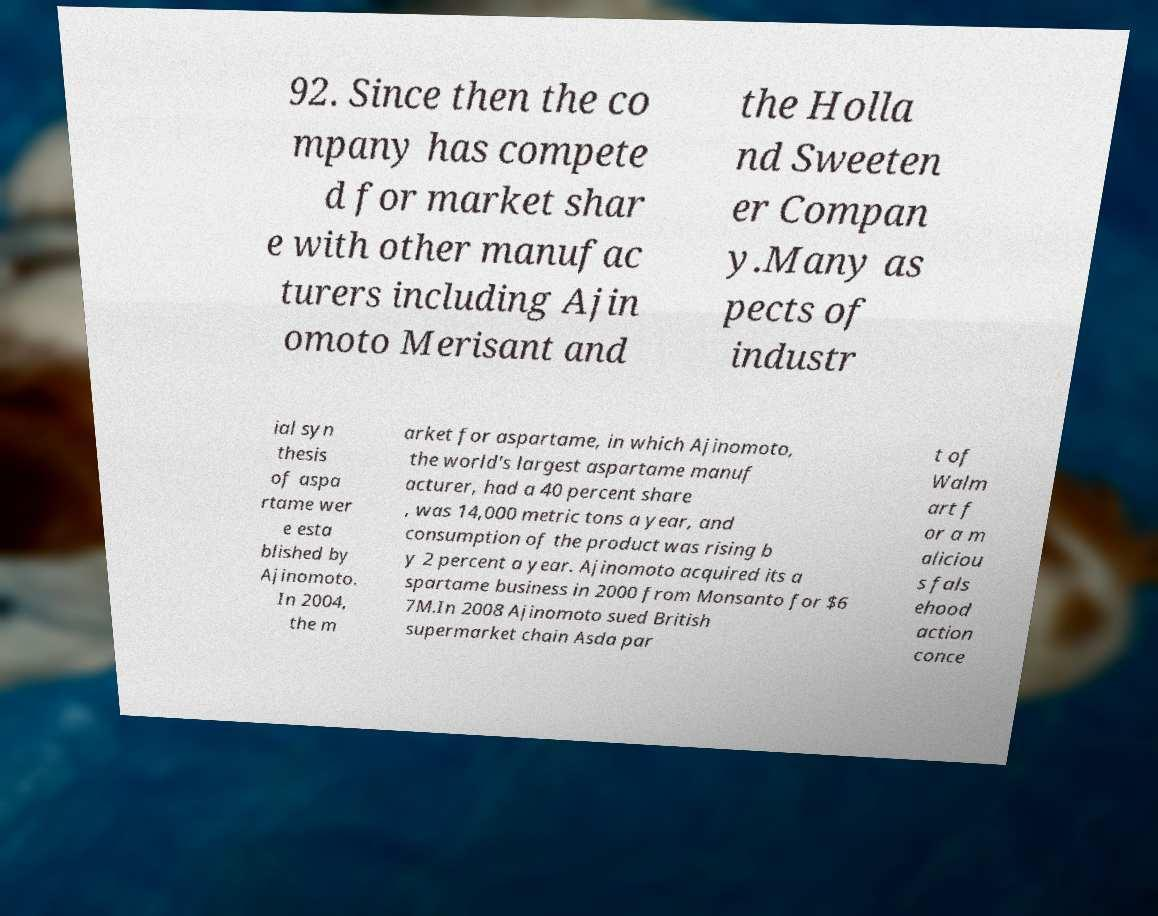Can you accurately transcribe the text from the provided image for me? 92. Since then the co mpany has compete d for market shar e with other manufac turers including Ajin omoto Merisant and the Holla nd Sweeten er Compan y.Many as pects of industr ial syn thesis of aspa rtame wer e esta blished by Ajinomoto. In 2004, the m arket for aspartame, in which Ajinomoto, the world's largest aspartame manuf acturer, had a 40 percent share , was 14,000 metric tons a year, and consumption of the product was rising b y 2 percent a year. Ajinomoto acquired its a spartame business in 2000 from Monsanto for $6 7M.In 2008 Ajinomoto sued British supermarket chain Asda par t of Walm art f or a m aliciou s fals ehood action conce 